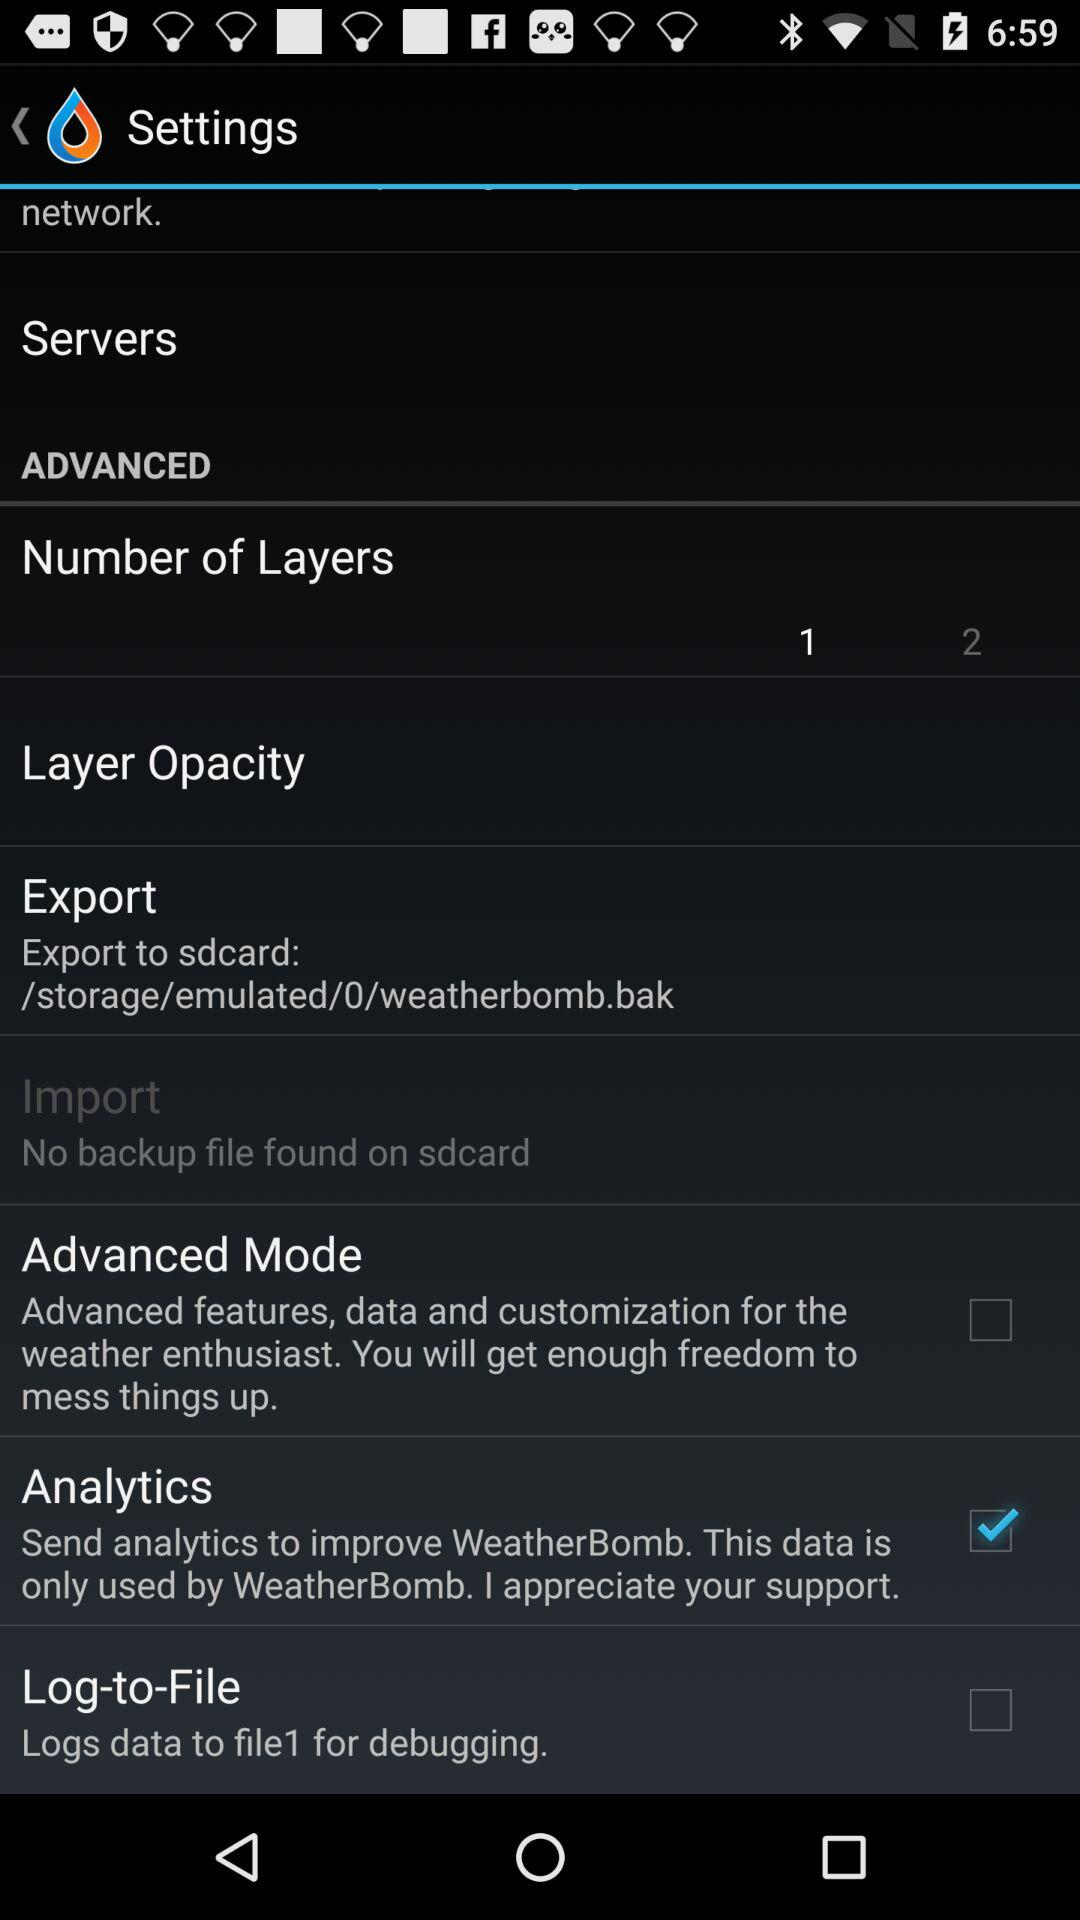What is the status of "Advanced Mode"? The status is "off". 